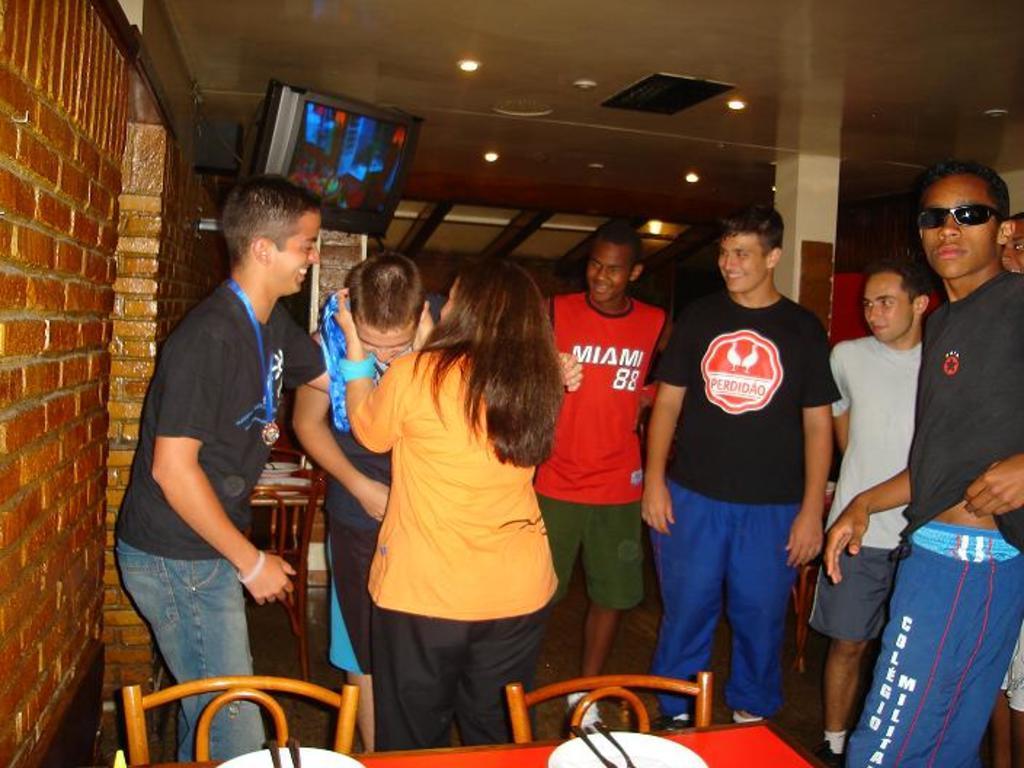Can you describe this image briefly? There are few people here standing and laughing. Behind them there is a TV. In front of them there is a table and chair. 